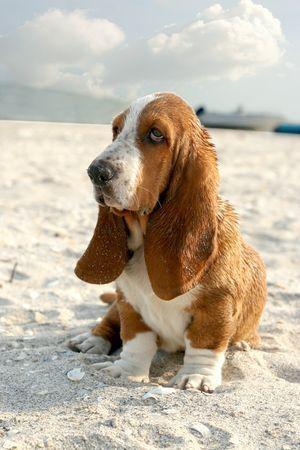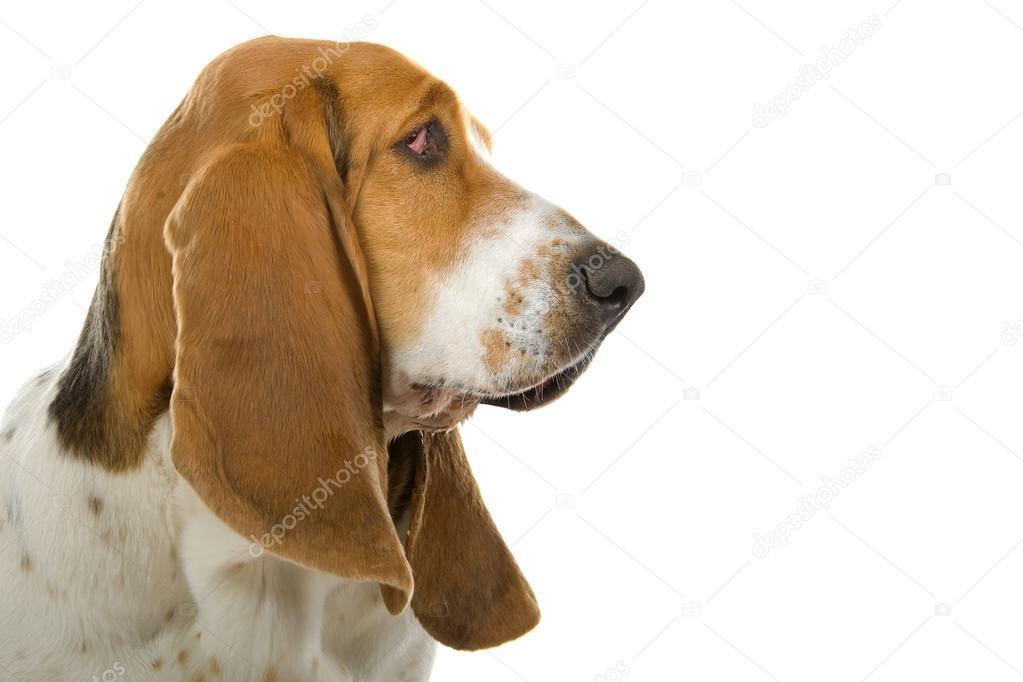The first image is the image on the left, the second image is the image on the right. Considering the images on both sides, is "there is a dog lying on the ground" valid? Answer yes or no. No. 